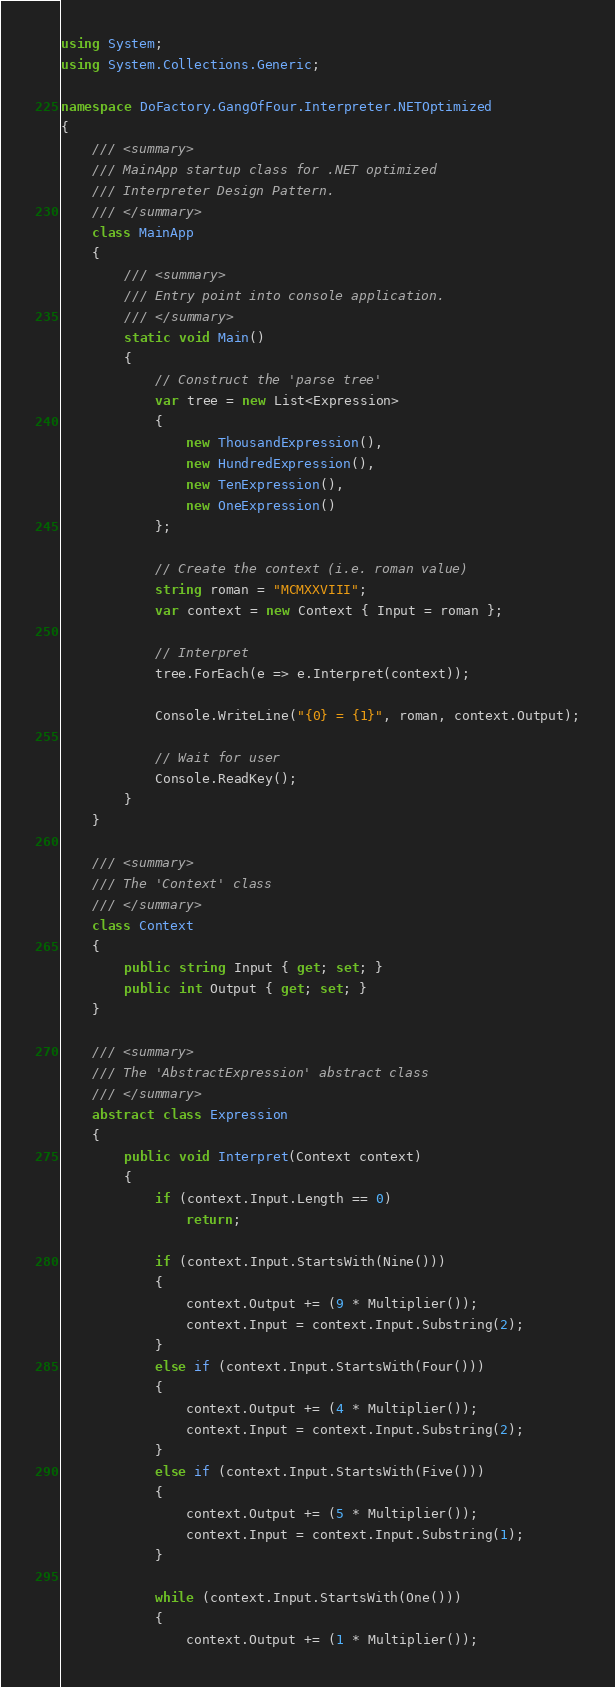Convert code to text. <code><loc_0><loc_0><loc_500><loc_500><_C#_>using System;
using System.Collections.Generic;

namespace DoFactory.GangOfFour.Interpreter.NETOptimized
{
    /// <summary>
    /// MainApp startup class for .NET optimized 
    /// Interpreter Design Pattern.
    /// </summary>
    class MainApp
    {
        /// <summary>
        /// Entry point into console application.
        /// </summary>
        static void Main()
        {
            // Construct the 'parse tree'
            var tree = new List<Expression>
            {
                new ThousandExpression(),
                new HundredExpression(),
                new TenExpression(),
                new OneExpression()
            };

            // Create the context (i.e. roman value)
            string roman = "MCMXXVIII";
            var context = new Context { Input = roman };

            // Interpret
            tree.ForEach(e => e.Interpret(context));

            Console.WriteLine("{0} = {1}", roman, context.Output);

            // Wait for user
            Console.ReadKey();
        }
    }

    /// <summary>
    /// The 'Context' class
    /// </summary>
    class Context
    {
        public string Input { get; set; }
        public int Output { get; set; }
    }

    /// <summary>
    /// The 'AbstractExpression' abstract class
    /// </summary>
    abstract class Expression
    {
        public void Interpret(Context context)
        {
            if (context.Input.Length == 0)
                return;

            if (context.Input.StartsWith(Nine()))
            {
                context.Output += (9 * Multiplier());
                context.Input = context.Input.Substring(2);
            }
            else if (context.Input.StartsWith(Four()))
            {
                context.Output += (4 * Multiplier());
                context.Input = context.Input.Substring(2);
            }
            else if (context.Input.StartsWith(Five()))
            {
                context.Output += (5 * Multiplier());
                context.Input = context.Input.Substring(1);
            }

            while (context.Input.StartsWith(One()))
            {
                context.Output += (1 * Multiplier());</code> 